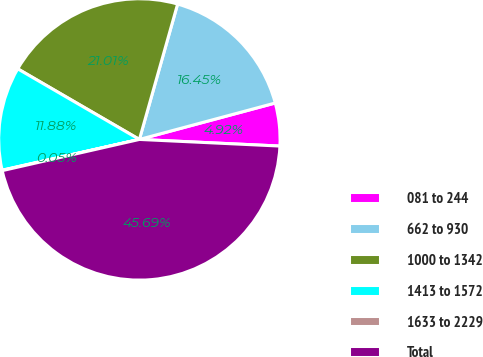Convert chart. <chart><loc_0><loc_0><loc_500><loc_500><pie_chart><fcel>081 to 244<fcel>662 to 930<fcel>1000 to 1342<fcel>1413 to 1572<fcel>1633 to 2229<fcel>Total<nl><fcel>4.92%<fcel>16.45%<fcel>21.01%<fcel>11.88%<fcel>0.05%<fcel>45.69%<nl></chart> 